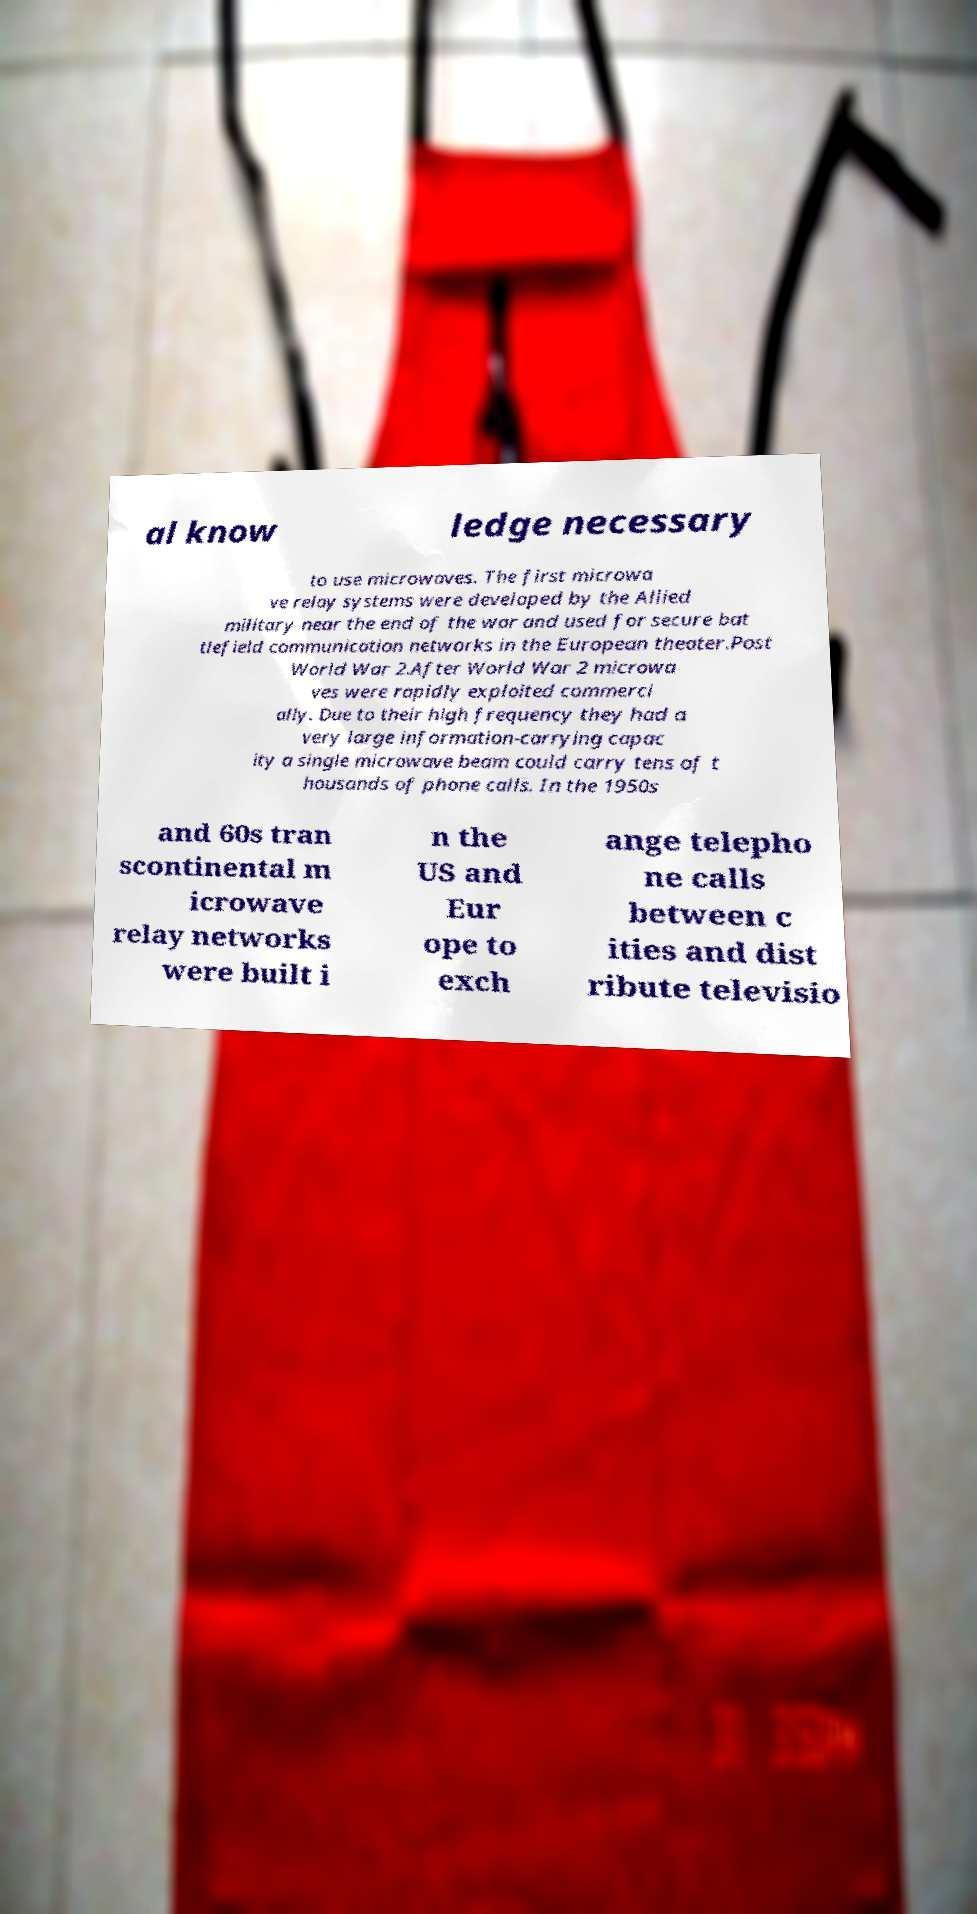For documentation purposes, I need the text within this image transcribed. Could you provide that? al know ledge necessary to use microwaves. The first microwa ve relay systems were developed by the Allied military near the end of the war and used for secure bat tlefield communication networks in the European theater.Post World War 2.After World War 2 microwa ves were rapidly exploited commerci ally. Due to their high frequency they had a very large information-carrying capac ity a single microwave beam could carry tens of t housands of phone calls. In the 1950s and 60s tran scontinental m icrowave relay networks were built i n the US and Eur ope to exch ange telepho ne calls between c ities and dist ribute televisio 